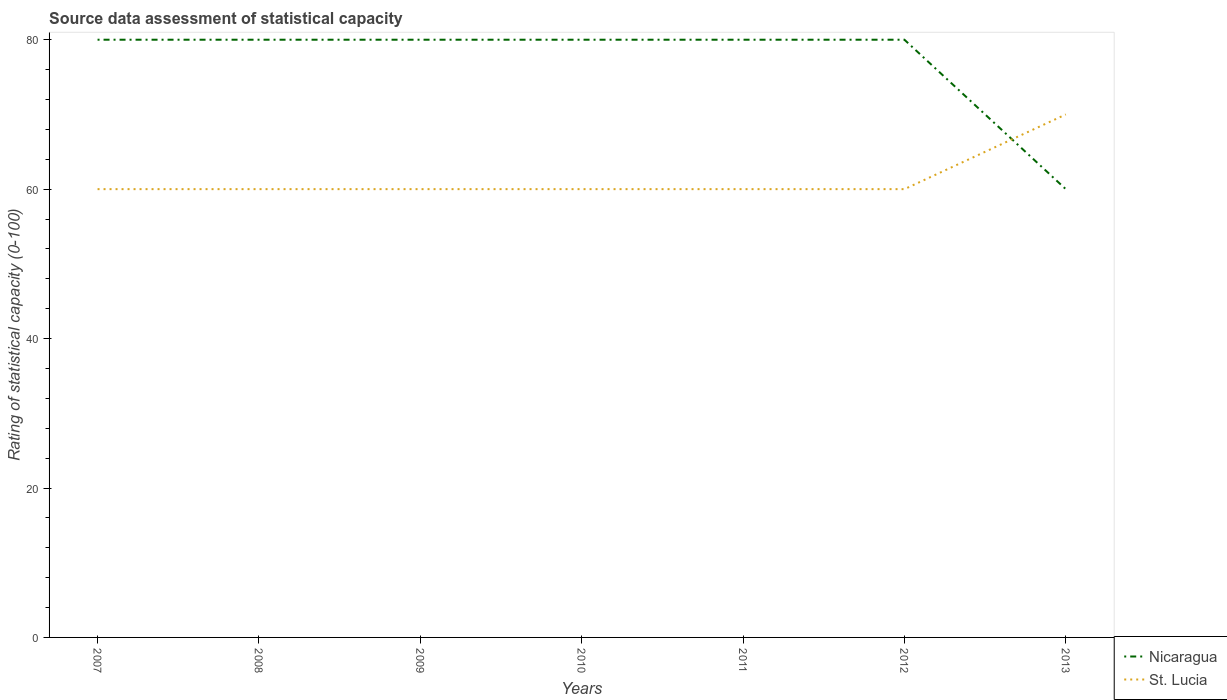How many different coloured lines are there?
Provide a succinct answer. 2. Across all years, what is the maximum rating of statistical capacity in St. Lucia?
Your answer should be compact. 60. In which year was the rating of statistical capacity in Nicaragua maximum?
Provide a succinct answer. 2013. What is the total rating of statistical capacity in Nicaragua in the graph?
Provide a succinct answer. 0. What is the difference between the highest and the second highest rating of statistical capacity in Nicaragua?
Ensure brevity in your answer.  20. Is the rating of statistical capacity in Nicaragua strictly greater than the rating of statistical capacity in St. Lucia over the years?
Keep it short and to the point. No. How many years are there in the graph?
Provide a short and direct response. 7. What is the difference between two consecutive major ticks on the Y-axis?
Your answer should be compact. 20. Are the values on the major ticks of Y-axis written in scientific E-notation?
Keep it short and to the point. No. Where does the legend appear in the graph?
Keep it short and to the point. Bottom right. What is the title of the graph?
Provide a succinct answer. Source data assessment of statistical capacity. Does "Congo (Republic)" appear as one of the legend labels in the graph?
Your answer should be very brief. No. What is the label or title of the Y-axis?
Provide a short and direct response. Rating of statistical capacity (0-100). What is the Rating of statistical capacity (0-100) in St. Lucia in 2007?
Offer a terse response. 60. What is the Rating of statistical capacity (0-100) in Nicaragua in 2009?
Your answer should be very brief. 80. What is the Rating of statistical capacity (0-100) in St. Lucia in 2011?
Offer a terse response. 60. What is the Rating of statistical capacity (0-100) of Nicaragua in 2012?
Make the answer very short. 80. What is the Rating of statistical capacity (0-100) of St. Lucia in 2012?
Keep it short and to the point. 60. What is the Rating of statistical capacity (0-100) of Nicaragua in 2013?
Your answer should be very brief. 60. Across all years, what is the maximum Rating of statistical capacity (0-100) in Nicaragua?
Offer a terse response. 80. Across all years, what is the maximum Rating of statistical capacity (0-100) in St. Lucia?
Your answer should be very brief. 70. Across all years, what is the minimum Rating of statistical capacity (0-100) in Nicaragua?
Your answer should be very brief. 60. What is the total Rating of statistical capacity (0-100) of Nicaragua in the graph?
Offer a terse response. 540. What is the total Rating of statistical capacity (0-100) in St. Lucia in the graph?
Your response must be concise. 430. What is the difference between the Rating of statistical capacity (0-100) of Nicaragua in 2007 and that in 2009?
Offer a very short reply. 0. What is the difference between the Rating of statistical capacity (0-100) of St. Lucia in 2007 and that in 2009?
Offer a very short reply. 0. What is the difference between the Rating of statistical capacity (0-100) of St. Lucia in 2007 and that in 2010?
Ensure brevity in your answer.  0. What is the difference between the Rating of statistical capacity (0-100) of St. Lucia in 2007 and that in 2011?
Give a very brief answer. 0. What is the difference between the Rating of statistical capacity (0-100) in Nicaragua in 2007 and that in 2012?
Offer a terse response. 0. What is the difference between the Rating of statistical capacity (0-100) in St. Lucia in 2007 and that in 2012?
Provide a short and direct response. 0. What is the difference between the Rating of statistical capacity (0-100) of Nicaragua in 2007 and that in 2013?
Ensure brevity in your answer.  20. What is the difference between the Rating of statistical capacity (0-100) of St. Lucia in 2007 and that in 2013?
Give a very brief answer. -10. What is the difference between the Rating of statistical capacity (0-100) of St. Lucia in 2008 and that in 2009?
Keep it short and to the point. 0. What is the difference between the Rating of statistical capacity (0-100) in Nicaragua in 2008 and that in 2010?
Provide a succinct answer. 0. What is the difference between the Rating of statistical capacity (0-100) of St. Lucia in 2008 and that in 2010?
Make the answer very short. 0. What is the difference between the Rating of statistical capacity (0-100) in Nicaragua in 2008 and that in 2011?
Offer a terse response. 0. What is the difference between the Rating of statistical capacity (0-100) of St. Lucia in 2008 and that in 2012?
Keep it short and to the point. 0. What is the difference between the Rating of statistical capacity (0-100) of Nicaragua in 2008 and that in 2013?
Provide a succinct answer. 20. What is the difference between the Rating of statistical capacity (0-100) of St. Lucia in 2008 and that in 2013?
Offer a terse response. -10. What is the difference between the Rating of statistical capacity (0-100) of Nicaragua in 2009 and that in 2010?
Ensure brevity in your answer.  0. What is the difference between the Rating of statistical capacity (0-100) of Nicaragua in 2009 and that in 2011?
Your response must be concise. 0. What is the difference between the Rating of statistical capacity (0-100) in St. Lucia in 2009 and that in 2011?
Your response must be concise. 0. What is the difference between the Rating of statistical capacity (0-100) of Nicaragua in 2009 and that in 2012?
Make the answer very short. 0. What is the difference between the Rating of statistical capacity (0-100) of Nicaragua in 2009 and that in 2013?
Offer a very short reply. 20. What is the difference between the Rating of statistical capacity (0-100) of St. Lucia in 2009 and that in 2013?
Your answer should be very brief. -10. What is the difference between the Rating of statistical capacity (0-100) of Nicaragua in 2010 and that in 2012?
Give a very brief answer. 0. What is the difference between the Rating of statistical capacity (0-100) of Nicaragua in 2010 and that in 2013?
Offer a terse response. 20. What is the difference between the Rating of statistical capacity (0-100) of St. Lucia in 2010 and that in 2013?
Your answer should be very brief. -10. What is the difference between the Rating of statistical capacity (0-100) in St. Lucia in 2011 and that in 2012?
Give a very brief answer. 0. What is the difference between the Rating of statistical capacity (0-100) of Nicaragua in 2011 and that in 2013?
Give a very brief answer. 20. What is the difference between the Rating of statistical capacity (0-100) of St. Lucia in 2011 and that in 2013?
Offer a terse response. -10. What is the difference between the Rating of statistical capacity (0-100) of Nicaragua in 2012 and that in 2013?
Make the answer very short. 20. What is the difference between the Rating of statistical capacity (0-100) of St. Lucia in 2012 and that in 2013?
Give a very brief answer. -10. What is the difference between the Rating of statistical capacity (0-100) of Nicaragua in 2007 and the Rating of statistical capacity (0-100) of St. Lucia in 2008?
Offer a very short reply. 20. What is the difference between the Rating of statistical capacity (0-100) of Nicaragua in 2007 and the Rating of statistical capacity (0-100) of St. Lucia in 2009?
Your answer should be compact. 20. What is the difference between the Rating of statistical capacity (0-100) of Nicaragua in 2007 and the Rating of statistical capacity (0-100) of St. Lucia in 2010?
Your answer should be compact. 20. What is the difference between the Rating of statistical capacity (0-100) in Nicaragua in 2007 and the Rating of statistical capacity (0-100) in St. Lucia in 2012?
Provide a short and direct response. 20. What is the difference between the Rating of statistical capacity (0-100) in Nicaragua in 2008 and the Rating of statistical capacity (0-100) in St. Lucia in 2010?
Provide a succinct answer. 20. What is the difference between the Rating of statistical capacity (0-100) in Nicaragua in 2008 and the Rating of statistical capacity (0-100) in St. Lucia in 2011?
Your answer should be compact. 20. What is the difference between the Rating of statistical capacity (0-100) of Nicaragua in 2009 and the Rating of statistical capacity (0-100) of St. Lucia in 2010?
Your answer should be very brief. 20. What is the difference between the Rating of statistical capacity (0-100) of Nicaragua in 2009 and the Rating of statistical capacity (0-100) of St. Lucia in 2011?
Ensure brevity in your answer.  20. What is the difference between the Rating of statistical capacity (0-100) of Nicaragua in 2009 and the Rating of statistical capacity (0-100) of St. Lucia in 2012?
Keep it short and to the point. 20. What is the difference between the Rating of statistical capacity (0-100) of Nicaragua in 2010 and the Rating of statistical capacity (0-100) of St. Lucia in 2011?
Give a very brief answer. 20. What is the difference between the Rating of statistical capacity (0-100) of Nicaragua in 2011 and the Rating of statistical capacity (0-100) of St. Lucia in 2013?
Provide a short and direct response. 10. What is the average Rating of statistical capacity (0-100) in Nicaragua per year?
Provide a succinct answer. 77.14. What is the average Rating of statistical capacity (0-100) of St. Lucia per year?
Provide a short and direct response. 61.43. What is the ratio of the Rating of statistical capacity (0-100) of Nicaragua in 2007 to that in 2008?
Make the answer very short. 1. What is the ratio of the Rating of statistical capacity (0-100) of St. Lucia in 2007 to that in 2008?
Your answer should be compact. 1. What is the ratio of the Rating of statistical capacity (0-100) of St. Lucia in 2007 to that in 2009?
Ensure brevity in your answer.  1. What is the ratio of the Rating of statistical capacity (0-100) in St. Lucia in 2007 to that in 2010?
Provide a succinct answer. 1. What is the ratio of the Rating of statistical capacity (0-100) in Nicaragua in 2007 to that in 2011?
Your answer should be compact. 1. What is the ratio of the Rating of statistical capacity (0-100) in St. Lucia in 2007 to that in 2011?
Your answer should be very brief. 1. What is the ratio of the Rating of statistical capacity (0-100) of St. Lucia in 2007 to that in 2012?
Provide a short and direct response. 1. What is the ratio of the Rating of statistical capacity (0-100) in Nicaragua in 2007 to that in 2013?
Offer a terse response. 1.33. What is the ratio of the Rating of statistical capacity (0-100) in St. Lucia in 2007 to that in 2013?
Provide a short and direct response. 0.86. What is the ratio of the Rating of statistical capacity (0-100) of Nicaragua in 2008 to that in 2011?
Your response must be concise. 1. What is the ratio of the Rating of statistical capacity (0-100) in Nicaragua in 2008 to that in 2012?
Your answer should be compact. 1. What is the ratio of the Rating of statistical capacity (0-100) of St. Lucia in 2008 to that in 2012?
Offer a terse response. 1. What is the ratio of the Rating of statistical capacity (0-100) of Nicaragua in 2008 to that in 2013?
Give a very brief answer. 1.33. What is the ratio of the Rating of statistical capacity (0-100) in Nicaragua in 2009 to that in 2010?
Offer a very short reply. 1. What is the ratio of the Rating of statistical capacity (0-100) in Nicaragua in 2009 to that in 2011?
Your answer should be compact. 1. What is the ratio of the Rating of statistical capacity (0-100) in St. Lucia in 2009 to that in 2011?
Provide a short and direct response. 1. What is the ratio of the Rating of statistical capacity (0-100) of Nicaragua in 2009 to that in 2012?
Keep it short and to the point. 1. What is the ratio of the Rating of statistical capacity (0-100) in Nicaragua in 2009 to that in 2013?
Offer a very short reply. 1.33. What is the ratio of the Rating of statistical capacity (0-100) of St. Lucia in 2009 to that in 2013?
Offer a very short reply. 0.86. What is the ratio of the Rating of statistical capacity (0-100) of St. Lucia in 2010 to that in 2011?
Your response must be concise. 1. What is the ratio of the Rating of statistical capacity (0-100) in St. Lucia in 2010 to that in 2012?
Offer a very short reply. 1. What is the ratio of the Rating of statistical capacity (0-100) in Nicaragua in 2010 to that in 2013?
Offer a terse response. 1.33. What is the ratio of the Rating of statistical capacity (0-100) of St. Lucia in 2010 to that in 2013?
Provide a succinct answer. 0.86. What is the ratio of the Rating of statistical capacity (0-100) of St. Lucia in 2011 to that in 2012?
Your answer should be very brief. 1. What is the difference between the highest and the second highest Rating of statistical capacity (0-100) of Nicaragua?
Give a very brief answer. 0. What is the difference between the highest and the second highest Rating of statistical capacity (0-100) of St. Lucia?
Provide a succinct answer. 10. 